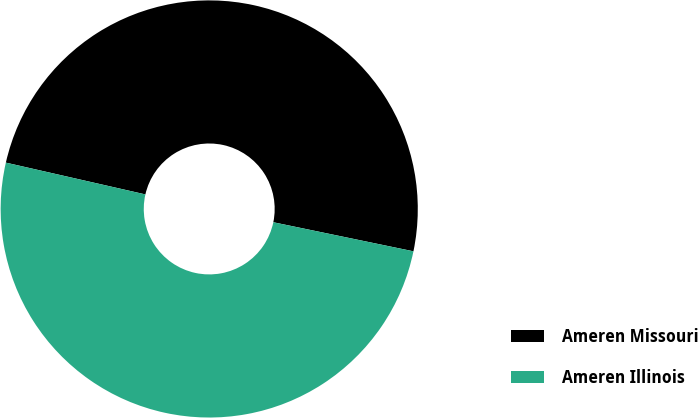<chart> <loc_0><loc_0><loc_500><loc_500><pie_chart><fcel>Ameren Missouri<fcel>Ameren Illinois<nl><fcel>49.69%<fcel>50.31%<nl></chart> 